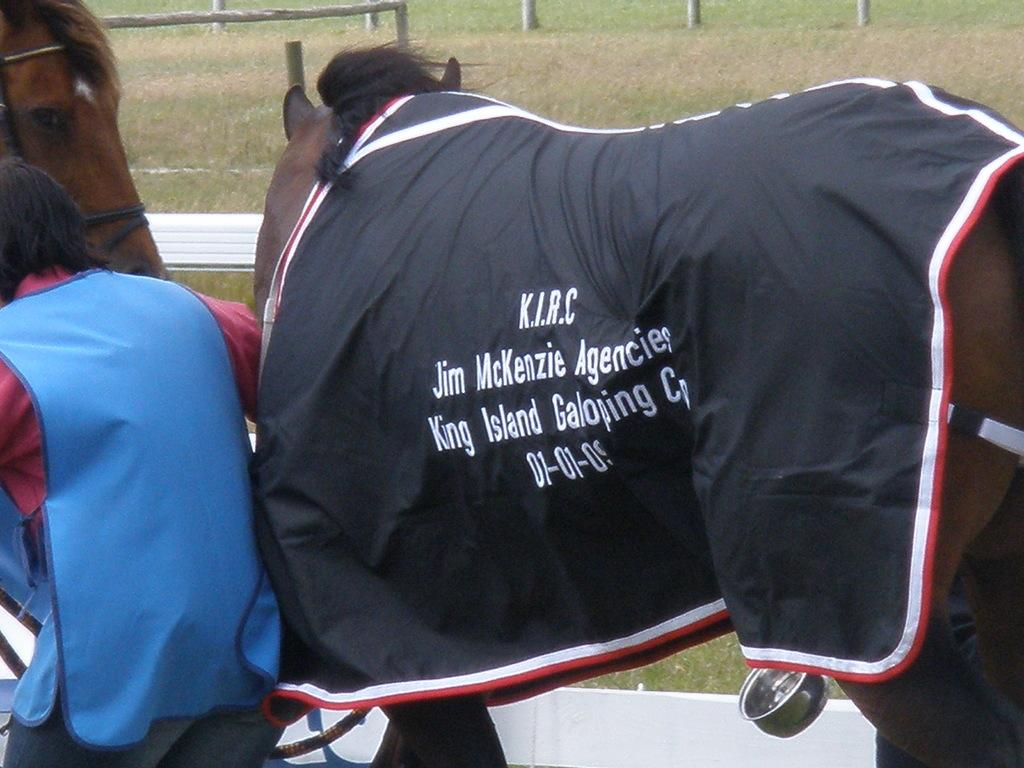What animals can be seen in the foreground of the picture? There are horses in the foreground of the picture. Who or what else is in the foreground of the picture? There is a person and a rope in the foreground of the picture. What else can be seen in the foreground of the picture? There is cloth and other objects in the foreground of the picture. What can be seen in the background of the picture? There is a field and fencing in the background of the picture. Can you see any screws on the dock in the image? There is no dock present in the image, and therefore no screws can be seen. Is the person in the image sinking into quicksand? There is no quicksand present in the image, and the person is standing on solid ground. 